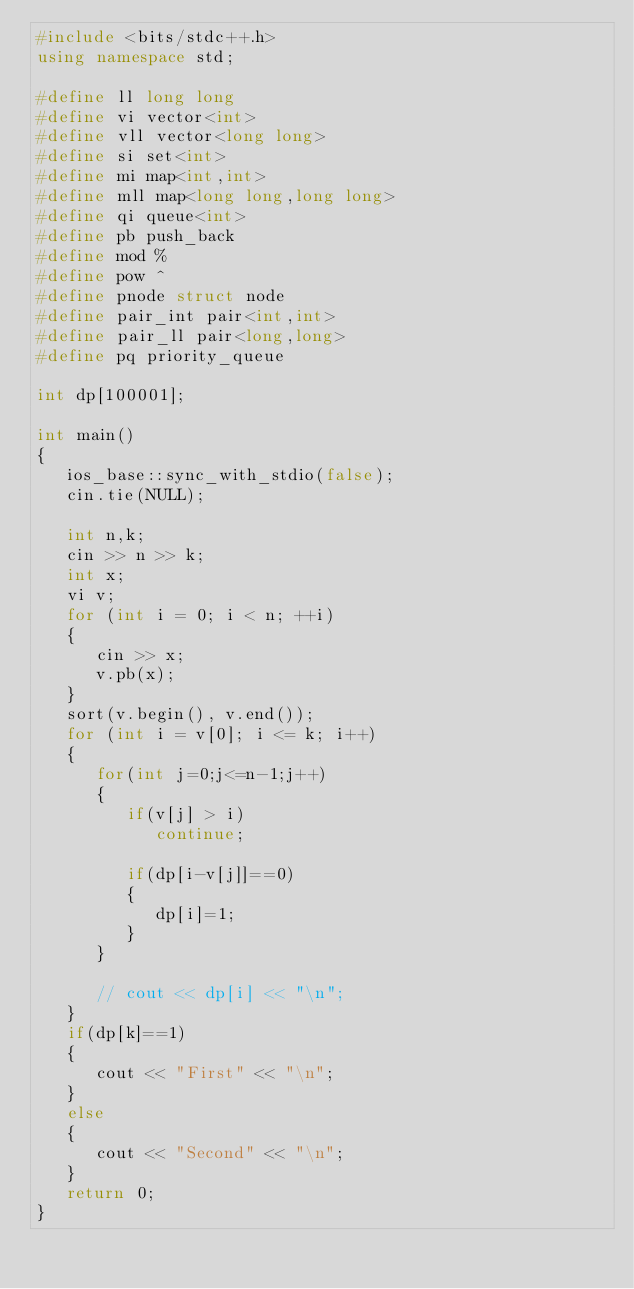Convert code to text. <code><loc_0><loc_0><loc_500><loc_500><_C++_>#include <bits/stdc++.h>
using namespace std;

#define ll long long
#define vi vector<int>
#define vll vector<long long>
#define si set<int>
#define mi map<int,int>
#define mll map<long long,long long>
#define qi queue<int>
#define pb push_back
#define mod %
#define pow ^
#define pnode struct node
#define pair_int pair<int,int>
#define pair_ll pair<long,long>
#define pq priority_queue

int dp[100001];

int main()
{
   ios_base::sync_with_stdio(false);
   cin.tie(NULL);

   int n,k;
   cin >> n >> k;
   int x;
   vi v;
   for (int i = 0; i < n; ++i)
   {
      cin >> x;
      v.pb(x);
   }
   sort(v.begin(), v.end());
   for (int i = v[0]; i <= k; i++)
   {
      for(int j=0;j<=n-1;j++)
      {
         if(v[j] > i)
            continue;

         if(dp[i-v[j]]==0)
         {
            dp[i]=1;
         }
      }
     
      // cout << dp[i] << "\n";
   }
   if(dp[k]==1)
   {
      cout << "First" << "\n";
   }
   else
   {
      cout << "Second" << "\n";
   }
   return 0;
}
</code> 